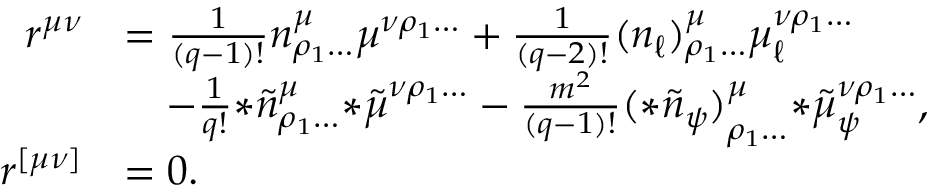Convert formula to latex. <formula><loc_0><loc_0><loc_500><loc_500>\begin{array} { r l } { r ^ { \mu \nu } } & { = \frac { 1 } { ( q - 1 ) ! } n ^ { \mu } _ { \rho _ { 1 } \dots } \mu ^ { \nu \rho _ { 1 } \dots } + \frac { 1 } { ( q - 2 ) ! } ( n _ { \ell } ) ^ { \mu } _ { \rho _ { 1 } \dots } \mu _ { \ell } ^ { \nu \rho _ { 1 } \dots } } \\ & { \quad - \frac { 1 } { q ! } { * \tilde { n } } ^ { \mu } _ { \rho _ { 1 } \dots } { * \tilde { \mu } } ^ { \nu \rho _ { 1 } \dots } - \frac { m ^ { 2 } } { ( q - 1 ) ! } { ( * \tilde { n } _ { \psi } ) } ^ { \mu } _ { \rho _ { 1 } \dots } { * \tilde { \mu } } _ { \psi } ^ { \nu \rho _ { 1 } \dots } , } \\ { r ^ { [ \mu \nu ] } } & { = 0 . } \end{array}</formula> 